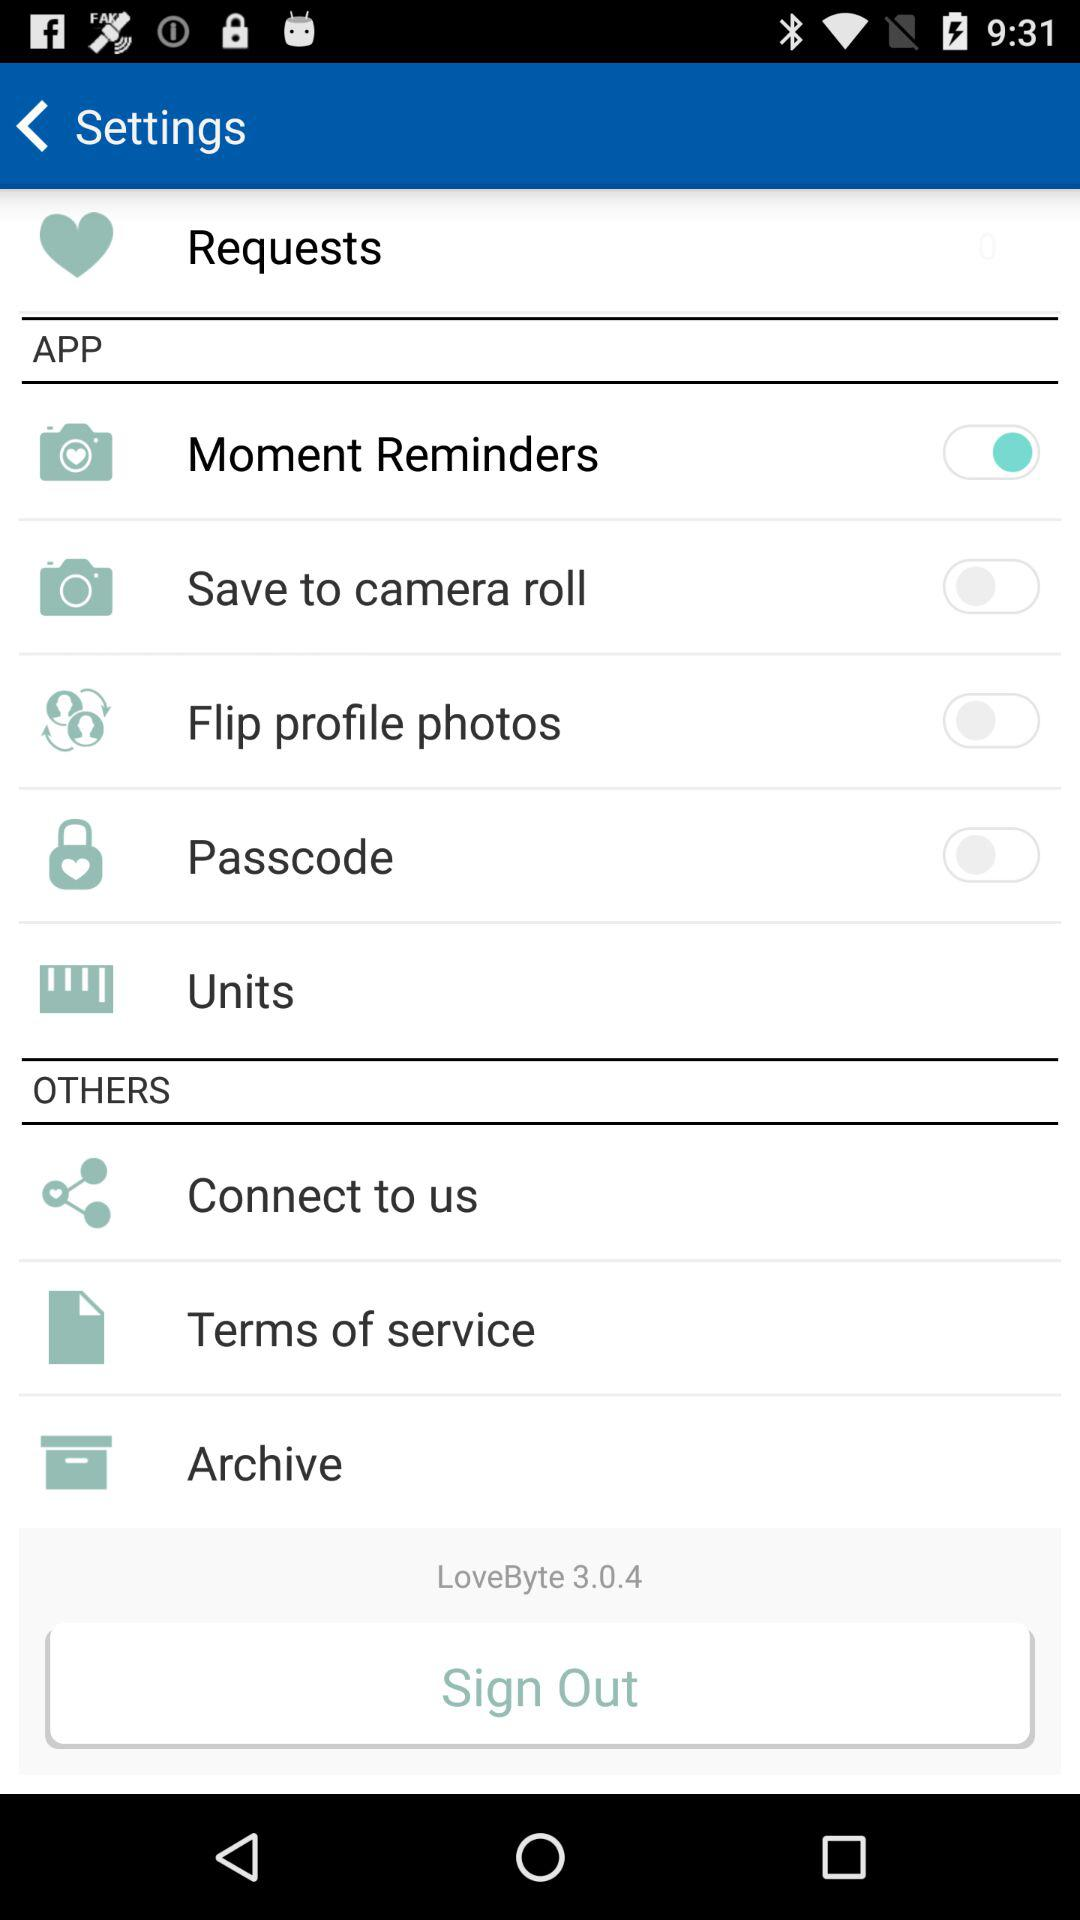What is the version of this app? The version is 3.0.4. 